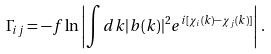Convert formula to latex. <formula><loc_0><loc_0><loc_500><loc_500>\Gamma _ { i j } = - f \ln \left | \int d k | b ( k ) | ^ { 2 } e ^ { i [ \chi _ { i } ( k ) - \chi _ { j } ( k ) ] } \right | \, .</formula> 